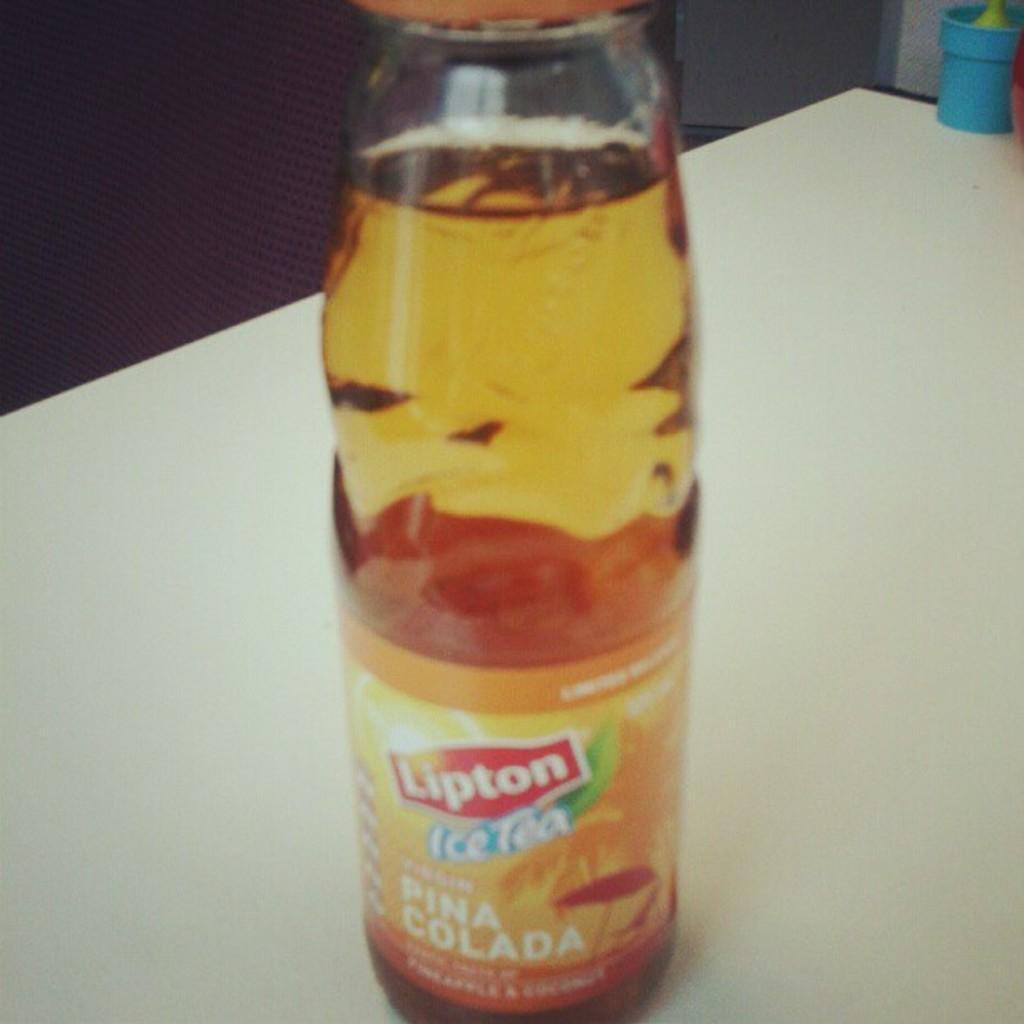Can you describe this image briefly? This is a picture of a bottle which is in orange color and kept on the white table and on the bottle it is written as lipton ice tea. 